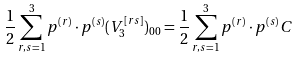Convert formula to latex. <formula><loc_0><loc_0><loc_500><loc_500>\frac { 1 } { 2 } \sum _ { r , s = 1 } ^ { 3 } p ^ { ( r ) } \cdot p ^ { ( s ) } ( V _ { 3 } ^ { [ r s ] } ) _ { 0 0 } = \frac { 1 } { 2 } \sum _ { r , s = 1 } ^ { 3 } p ^ { ( r ) } \cdot p ^ { ( s ) } C</formula> 